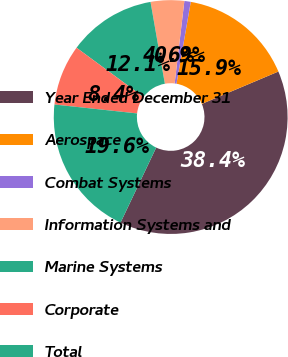<chart> <loc_0><loc_0><loc_500><loc_500><pie_chart><fcel>Year Ended December 31<fcel>Aerospace<fcel>Combat Systems<fcel>Information Systems and<fcel>Marine Systems<fcel>Corporate<fcel>Total<nl><fcel>38.42%<fcel>15.89%<fcel>0.88%<fcel>4.63%<fcel>12.14%<fcel>8.39%<fcel>19.65%<nl></chart> 